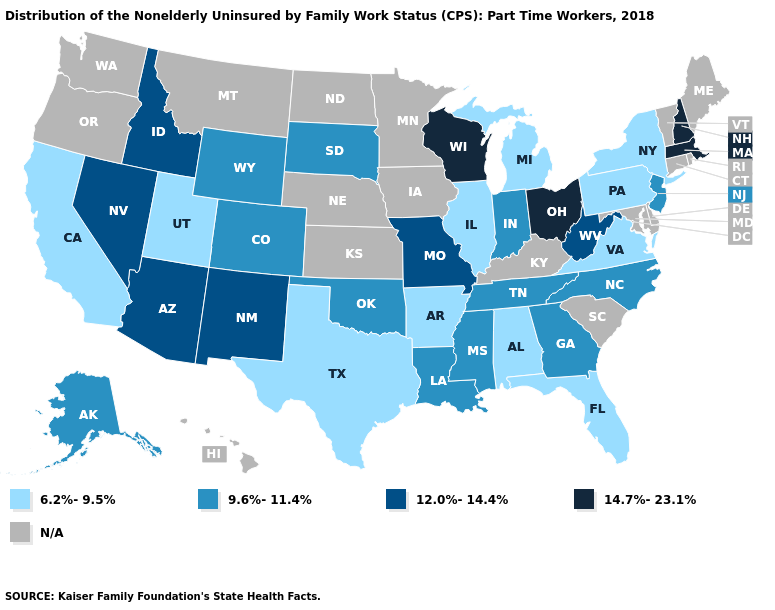Does Colorado have the highest value in the USA?
Answer briefly. No. What is the lowest value in the USA?
Quick response, please. 6.2%-9.5%. What is the highest value in the USA?
Keep it brief. 14.7%-23.1%. What is the value of Oregon?
Keep it brief. N/A. What is the value of Maine?
Be succinct. N/A. Does the first symbol in the legend represent the smallest category?
Answer briefly. Yes. Name the states that have a value in the range N/A?
Be succinct. Connecticut, Delaware, Hawaii, Iowa, Kansas, Kentucky, Maine, Maryland, Minnesota, Montana, Nebraska, North Dakota, Oregon, Rhode Island, South Carolina, Vermont, Washington. Among the states that border Nevada , does Arizona have the lowest value?
Be succinct. No. What is the highest value in states that border Oregon?
Answer briefly. 12.0%-14.4%. What is the value of New Mexico?
Concise answer only. 12.0%-14.4%. What is the highest value in the West ?
Be succinct. 12.0%-14.4%. Among the states that border Michigan , which have the lowest value?
Keep it brief. Indiana. Name the states that have a value in the range 14.7%-23.1%?
Give a very brief answer. Massachusetts, New Hampshire, Ohio, Wisconsin. Name the states that have a value in the range 9.6%-11.4%?
Write a very short answer. Alaska, Colorado, Georgia, Indiana, Louisiana, Mississippi, New Jersey, North Carolina, Oklahoma, South Dakota, Tennessee, Wyoming. 